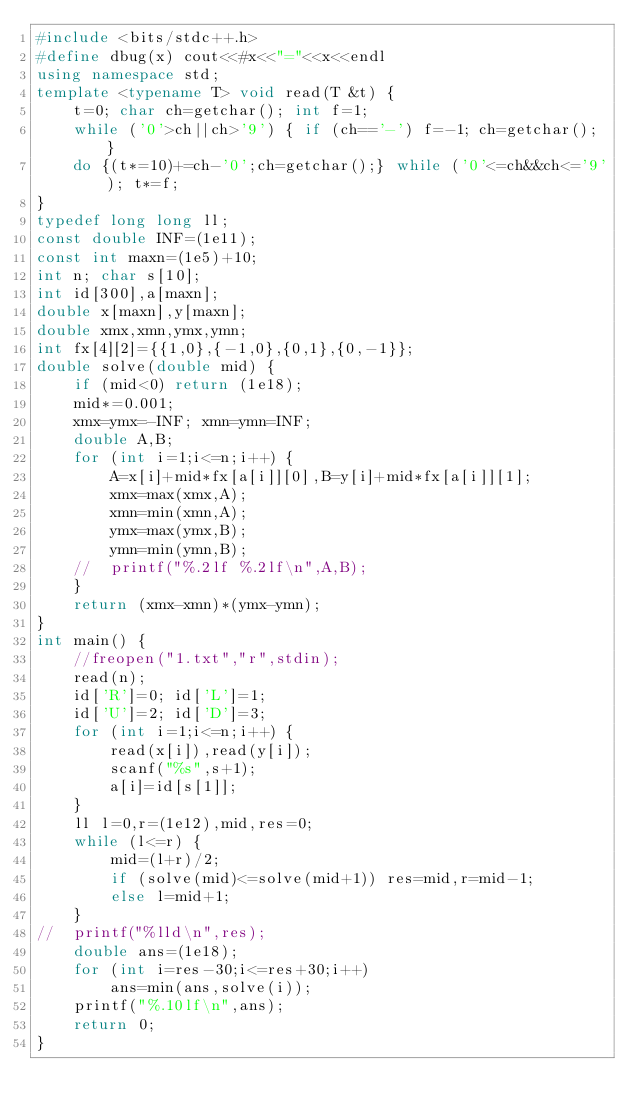Convert code to text. <code><loc_0><loc_0><loc_500><loc_500><_C++_>#include <bits/stdc++.h>
#define dbug(x) cout<<#x<<"="<<x<<endl
using namespace std;
template <typename T> void read(T &t) {
	t=0; char ch=getchar(); int f=1;
	while ('0'>ch||ch>'9') { if (ch=='-') f=-1; ch=getchar(); }
	do {(t*=10)+=ch-'0';ch=getchar();} while ('0'<=ch&&ch<='9'); t*=f;
}
typedef long long ll;
const double INF=(1e11);
const int maxn=(1e5)+10;
int n; char s[10];
int id[300],a[maxn];
double x[maxn],y[maxn];
double xmx,xmn,ymx,ymn;
int fx[4][2]={{1,0},{-1,0},{0,1},{0,-1}};
double solve(double mid) {
	if (mid<0) return (1e18);
	mid*=0.001;
	xmx=ymx=-INF; xmn=ymn=INF;
	double A,B;
	for (int i=1;i<=n;i++) {
		A=x[i]+mid*fx[a[i]][0],B=y[i]+mid*fx[a[i]][1];
		xmx=max(xmx,A);
		xmn=min(xmn,A);
		ymx=max(ymx,B);
		ymn=min(ymn,B);
	//	printf("%.2lf %.2lf\n",A,B);
	}
	return (xmx-xmn)*(ymx-ymn);
}
int main() {
	//freopen("1.txt","r",stdin);
	read(n);
	id['R']=0; id['L']=1;
	id['U']=2; id['D']=3;
	for (int i=1;i<=n;i++) {
		read(x[i]),read(y[i]);
		scanf("%s",s+1);
		a[i]=id[s[1]];
	}
	ll l=0,r=(1e12),mid,res=0;
	while (l<=r) {
		mid=(l+r)/2;
		if (solve(mid)<=solve(mid+1)) res=mid,r=mid-1;
		else l=mid+1;
	}
//	printf("%lld\n",res);
	double ans=(1e18);
	for (int i=res-30;i<=res+30;i++)
		ans=min(ans,solve(i));
	printf("%.10lf\n",ans);
	return 0;
}</code> 